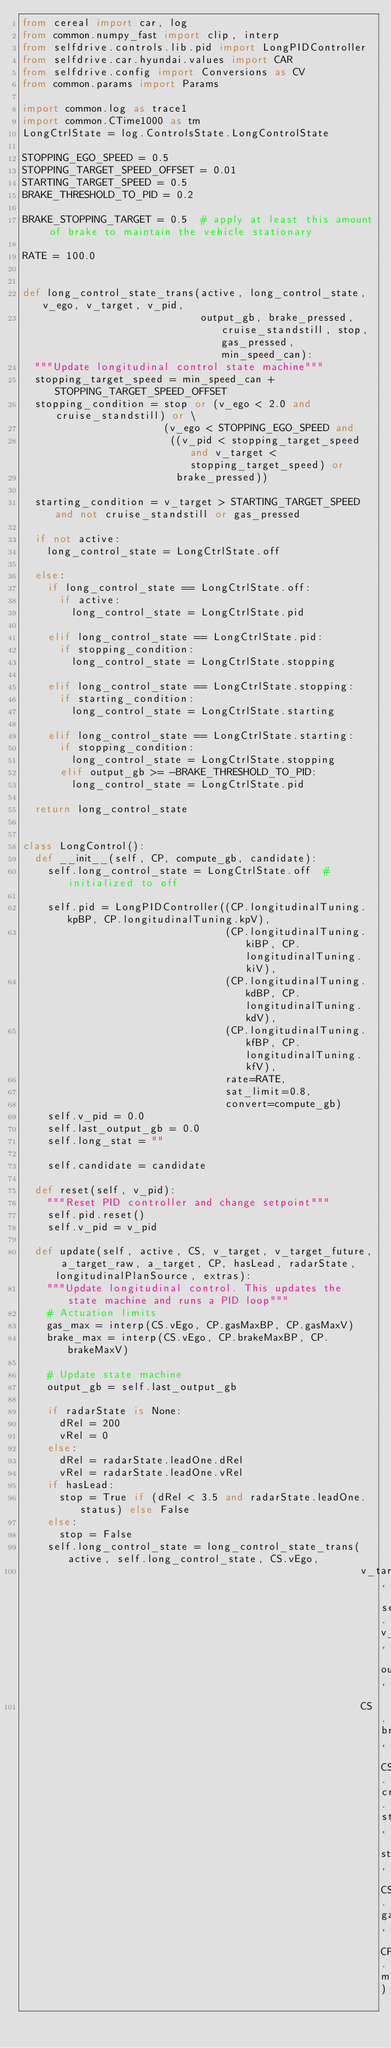Convert code to text. <code><loc_0><loc_0><loc_500><loc_500><_Python_>from cereal import car, log
from common.numpy_fast import clip, interp
from selfdrive.controls.lib.pid import LongPIDController
from selfdrive.car.hyundai.values import CAR
from selfdrive.config import Conversions as CV
from common.params import Params

import common.log as trace1
import common.CTime1000 as tm
LongCtrlState = log.ControlsState.LongControlState

STOPPING_EGO_SPEED = 0.5
STOPPING_TARGET_SPEED_OFFSET = 0.01
STARTING_TARGET_SPEED = 0.5
BRAKE_THRESHOLD_TO_PID = 0.2

BRAKE_STOPPING_TARGET = 0.5  # apply at least this amount of brake to maintain the vehicle stationary

RATE = 100.0


def long_control_state_trans(active, long_control_state, v_ego, v_target, v_pid,
                             output_gb, brake_pressed, cruise_standstill, stop, gas_pressed, min_speed_can):
  """Update longitudinal control state machine"""
  stopping_target_speed = min_speed_can + STOPPING_TARGET_SPEED_OFFSET
  stopping_condition = stop or (v_ego < 2.0 and cruise_standstill) or \
                       (v_ego < STOPPING_EGO_SPEED and
                        ((v_pid < stopping_target_speed and v_target < stopping_target_speed) or
                         brake_pressed))

  starting_condition = v_target > STARTING_TARGET_SPEED and not cruise_standstill or gas_pressed

  if not active:
    long_control_state = LongCtrlState.off

  else:
    if long_control_state == LongCtrlState.off:
      if active:
        long_control_state = LongCtrlState.pid

    elif long_control_state == LongCtrlState.pid:
      if stopping_condition:
        long_control_state = LongCtrlState.stopping

    elif long_control_state == LongCtrlState.stopping:
      if starting_condition:
        long_control_state = LongCtrlState.starting

    elif long_control_state == LongCtrlState.starting:
      if stopping_condition:
        long_control_state = LongCtrlState.stopping
      elif output_gb >= -BRAKE_THRESHOLD_TO_PID:
        long_control_state = LongCtrlState.pid

  return long_control_state


class LongControl():
  def __init__(self, CP, compute_gb, candidate):
    self.long_control_state = LongCtrlState.off  # initialized to off

    self.pid = LongPIDController((CP.longitudinalTuning.kpBP, CP.longitudinalTuning.kpV),
                                 (CP.longitudinalTuning.kiBP, CP.longitudinalTuning.kiV),
                                 (CP.longitudinalTuning.kdBP, CP.longitudinalTuning.kdV),
                                 (CP.longitudinalTuning.kfBP, CP.longitudinalTuning.kfV),
                                 rate=RATE,
                                 sat_limit=0.8,
                                 convert=compute_gb)
    self.v_pid = 0.0
    self.last_output_gb = 0.0
    self.long_stat = ""

    self.candidate = candidate

  def reset(self, v_pid):
    """Reset PID controller and change setpoint"""
    self.pid.reset()
    self.v_pid = v_pid

  def update(self, active, CS, v_target, v_target_future, a_target_raw, a_target, CP, hasLead, radarState, longitudinalPlanSource, extras):
    """Update longitudinal control. This updates the state machine and runs a PID loop"""
    # Actuation limits
    gas_max = interp(CS.vEgo, CP.gasMaxBP, CP.gasMaxV)
    brake_max = interp(CS.vEgo, CP.brakeMaxBP, CP.brakeMaxV)

    # Update state machine
    output_gb = self.last_output_gb

    if radarState is None:
      dRel = 200
      vRel = 0
    else:
      dRel = radarState.leadOne.dRel
      vRel = radarState.leadOne.vRel
    if hasLead:
      stop = True if (dRel < 3.5 and radarState.leadOne.status) else False
    else:
      stop = False
    self.long_control_state = long_control_state_trans(active, self.long_control_state, CS.vEgo,
                                                       v_target_future, self.v_pid, output_gb,
                                                       CS.brakePressed, CS.cruiseState.standstill, stop, CS.gasPressed, CP.minSpeedCan)
</code> 